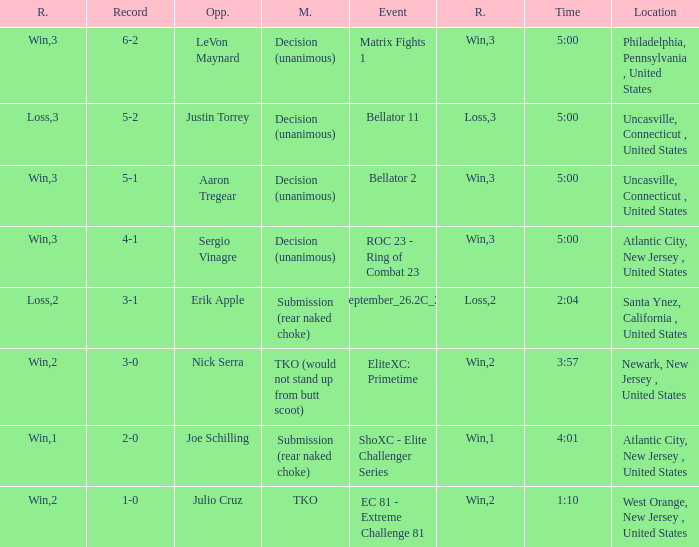Who was the opponent when there was a TKO method? Julio Cruz. 